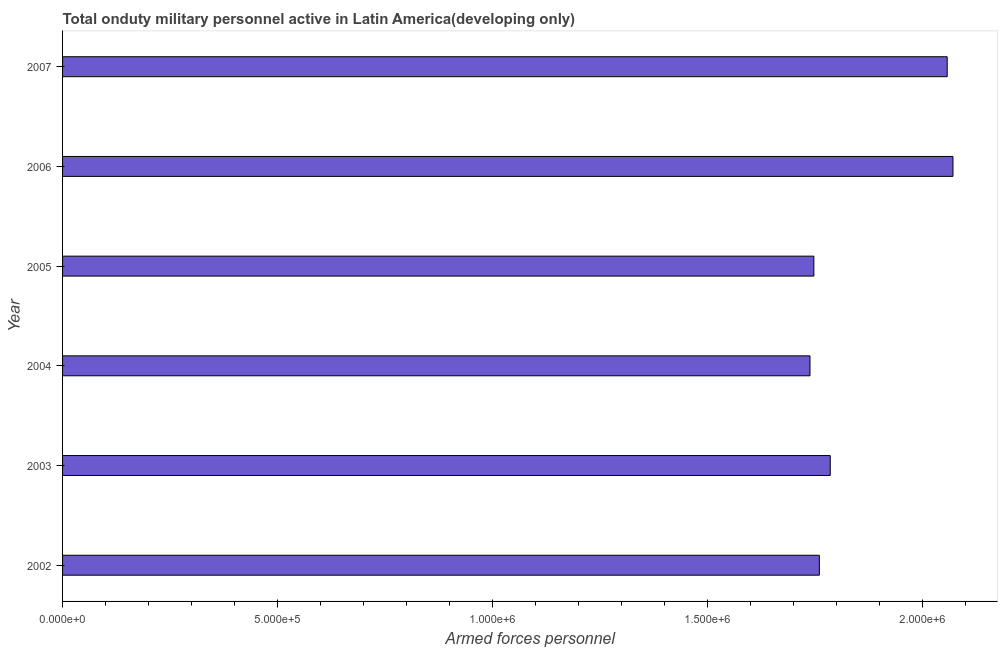Does the graph contain any zero values?
Ensure brevity in your answer.  No. Does the graph contain grids?
Your answer should be very brief. No. What is the title of the graph?
Ensure brevity in your answer.  Total onduty military personnel active in Latin America(developing only). What is the label or title of the X-axis?
Ensure brevity in your answer.  Armed forces personnel. What is the number of armed forces personnel in 2004?
Keep it short and to the point. 1.74e+06. Across all years, what is the maximum number of armed forces personnel?
Give a very brief answer. 2.07e+06. Across all years, what is the minimum number of armed forces personnel?
Make the answer very short. 1.74e+06. In which year was the number of armed forces personnel minimum?
Keep it short and to the point. 2004. What is the sum of the number of armed forces personnel?
Make the answer very short. 1.12e+07. What is the difference between the number of armed forces personnel in 2002 and 2007?
Your response must be concise. -2.97e+05. What is the average number of armed forces personnel per year?
Give a very brief answer. 1.86e+06. What is the median number of armed forces personnel?
Your answer should be very brief. 1.77e+06. In how many years, is the number of armed forces personnel greater than 900000 ?
Provide a succinct answer. 6. Do a majority of the years between 2006 and 2007 (inclusive) have number of armed forces personnel greater than 800000 ?
Your answer should be very brief. Yes. What is the ratio of the number of armed forces personnel in 2002 to that in 2007?
Give a very brief answer. 0.85. Is the difference between the number of armed forces personnel in 2003 and 2007 greater than the difference between any two years?
Your answer should be very brief. No. What is the difference between the highest and the second highest number of armed forces personnel?
Provide a succinct answer. 1.34e+04. What is the difference between the highest and the lowest number of armed forces personnel?
Ensure brevity in your answer.  3.33e+05. In how many years, is the number of armed forces personnel greater than the average number of armed forces personnel taken over all years?
Provide a short and direct response. 2. How many bars are there?
Your response must be concise. 6. Are the values on the major ticks of X-axis written in scientific E-notation?
Provide a succinct answer. Yes. What is the Armed forces personnel of 2002?
Ensure brevity in your answer.  1.76e+06. What is the Armed forces personnel of 2003?
Your answer should be very brief. 1.79e+06. What is the Armed forces personnel in 2004?
Ensure brevity in your answer.  1.74e+06. What is the Armed forces personnel in 2005?
Keep it short and to the point. 1.75e+06. What is the Armed forces personnel in 2006?
Provide a short and direct response. 2.07e+06. What is the Armed forces personnel in 2007?
Offer a very short reply. 2.06e+06. What is the difference between the Armed forces personnel in 2002 and 2003?
Offer a terse response. -2.53e+04. What is the difference between the Armed forces personnel in 2002 and 2004?
Provide a short and direct response. 2.18e+04. What is the difference between the Armed forces personnel in 2002 and 2005?
Your answer should be very brief. 1.28e+04. What is the difference between the Armed forces personnel in 2002 and 2006?
Offer a very short reply. -3.11e+05. What is the difference between the Armed forces personnel in 2002 and 2007?
Give a very brief answer. -2.97e+05. What is the difference between the Armed forces personnel in 2003 and 2004?
Your response must be concise. 4.71e+04. What is the difference between the Armed forces personnel in 2003 and 2005?
Your answer should be very brief. 3.81e+04. What is the difference between the Armed forces personnel in 2003 and 2006?
Your answer should be compact. -2.85e+05. What is the difference between the Armed forces personnel in 2003 and 2007?
Offer a very short reply. -2.72e+05. What is the difference between the Armed forces personnel in 2004 and 2005?
Your answer should be compact. -9000. What is the difference between the Armed forces personnel in 2004 and 2006?
Your answer should be very brief. -3.33e+05. What is the difference between the Armed forces personnel in 2004 and 2007?
Keep it short and to the point. -3.19e+05. What is the difference between the Armed forces personnel in 2005 and 2006?
Provide a succinct answer. -3.24e+05. What is the difference between the Armed forces personnel in 2005 and 2007?
Your answer should be compact. -3.10e+05. What is the difference between the Armed forces personnel in 2006 and 2007?
Provide a short and direct response. 1.34e+04. What is the ratio of the Armed forces personnel in 2002 to that in 2003?
Your answer should be compact. 0.99. What is the ratio of the Armed forces personnel in 2002 to that in 2005?
Ensure brevity in your answer.  1.01. What is the ratio of the Armed forces personnel in 2002 to that in 2006?
Ensure brevity in your answer.  0.85. What is the ratio of the Armed forces personnel in 2002 to that in 2007?
Your answer should be very brief. 0.85. What is the ratio of the Armed forces personnel in 2003 to that in 2006?
Offer a very short reply. 0.86. What is the ratio of the Armed forces personnel in 2003 to that in 2007?
Provide a short and direct response. 0.87. What is the ratio of the Armed forces personnel in 2004 to that in 2005?
Your response must be concise. 0.99. What is the ratio of the Armed forces personnel in 2004 to that in 2006?
Offer a very short reply. 0.84. What is the ratio of the Armed forces personnel in 2004 to that in 2007?
Your response must be concise. 0.84. What is the ratio of the Armed forces personnel in 2005 to that in 2006?
Offer a very short reply. 0.84. What is the ratio of the Armed forces personnel in 2005 to that in 2007?
Your response must be concise. 0.85. What is the ratio of the Armed forces personnel in 2006 to that in 2007?
Provide a succinct answer. 1.01. 